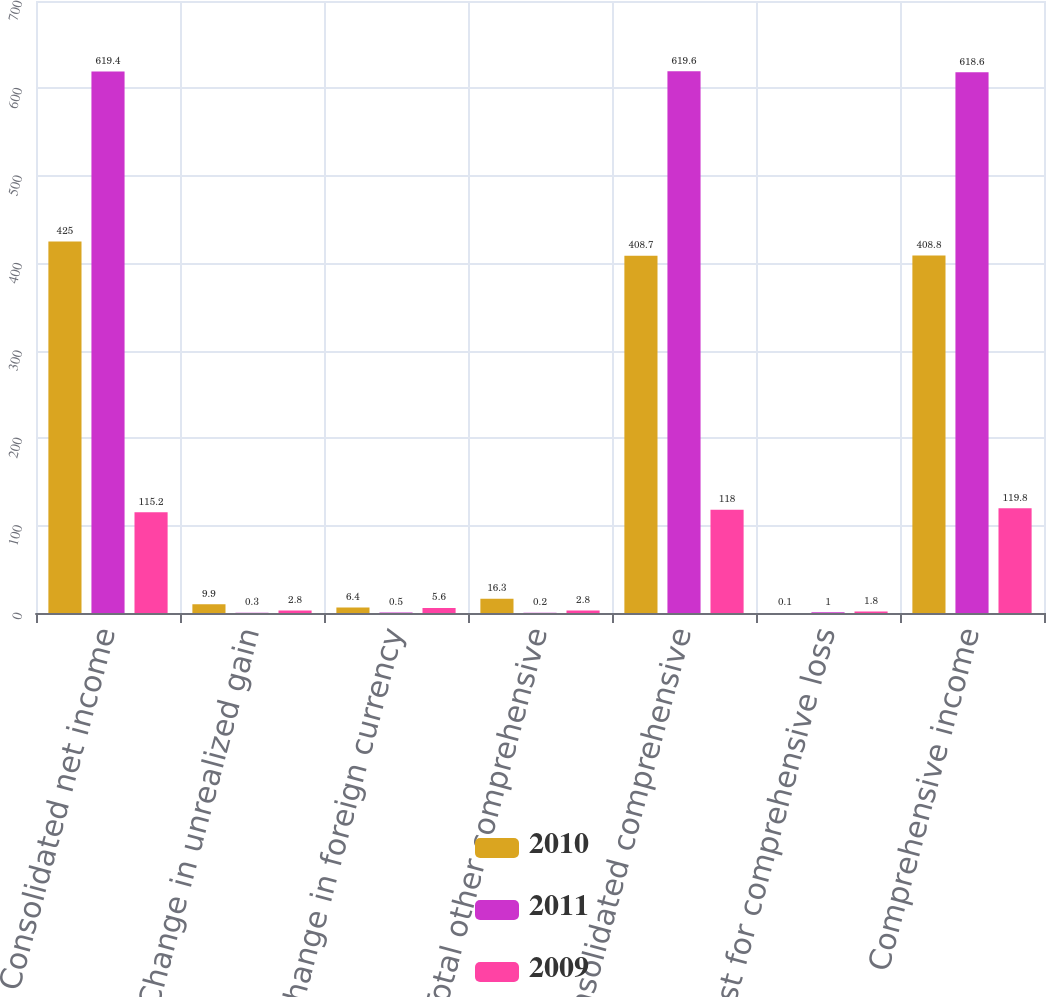Convert chart. <chart><loc_0><loc_0><loc_500><loc_500><stacked_bar_chart><ecel><fcel>Consolidated net income<fcel>Change in unrealized gain<fcel>Change in foreign currency<fcel>Total other comprehensive<fcel>Consolidated comprehensive<fcel>Adjust for comprehensive loss<fcel>Comprehensive income<nl><fcel>2010<fcel>425<fcel>9.9<fcel>6.4<fcel>16.3<fcel>408.7<fcel>0.1<fcel>408.8<nl><fcel>2011<fcel>619.4<fcel>0.3<fcel>0.5<fcel>0.2<fcel>619.6<fcel>1<fcel>618.6<nl><fcel>2009<fcel>115.2<fcel>2.8<fcel>5.6<fcel>2.8<fcel>118<fcel>1.8<fcel>119.8<nl></chart> 